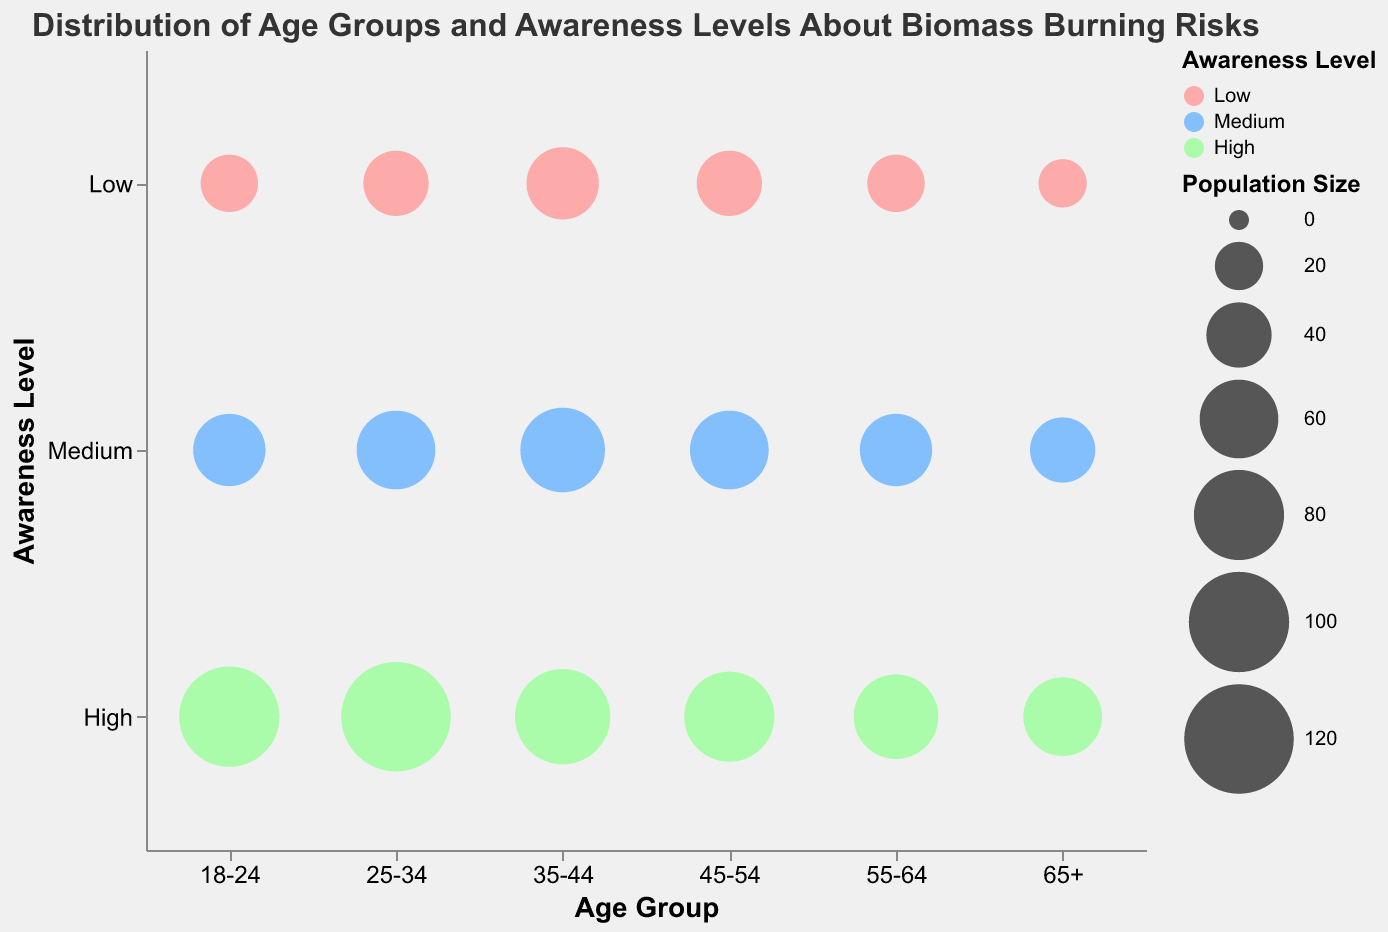What is the title of the chart? The title is displayed at the top of the chart and usually provides an overview of what the data represents. In this case, the words in the largest font at the top are the title.
Answer: Distribution of Age Groups and Awareness Levels About Biomass Burning Risks How many age groups are represented in the chart? The number of unique age groups can be counted on the x-axis. Each label on this axis indicates a unique age group.
Answer: 6 Which age group has the highest awareness level with the largest bubble size? Identify the 'High' awareness level on the y-axis and look at the bubble sizes for each age group in that row. The largest bubble will indicate the largest population size.
Answer: 25-34 Compare the bubble sizes for the 'Low' awareness level between the '18-24' and '65+' age groups. Which one is larger? Locate the 'Low' awareness level on the y-axis, then compare the bubbles for the '18-24' and '65+' age groups. The bubble with the larger size represents the larger population.
Answer: 18-24 What is the population size for the 'Medium' awareness level in the '35-44' age group? Find the intersection of the '35-44' age group on the x-axis and 'Medium' awareness level on the y-axis. The tooltip or the size of the bubble can provide an estimate of the population size.
Answer: 70 Which age group has the smallest population size for any awareness level? Look for the smallest bubble in the chart for any awareness level across all age groups.
Answer: 65+ at Low awareness level Is there a significant difference in population size for 'High' awareness levels across different age groups? Compare the bubble sizes in the row corresponding to 'High' awareness level across all age groups. Take note of any significantly larger or smaller bubbles.
Answer: Yes Among the age groups, which one has the smallest difference in population size between 'Low' and 'High' awareness levels? For each age group, calculate the difference in bubble size between 'Low' and 'High' awareness levels. The smallest difference indicates the age group with the least variation.
Answer: 55-64 How does the population size for 'Medium' awareness level compare between the '25-34' and '55-64' age groups? Locate the 'Medium' awareness level row and compare the sizes of the bubbles between the '25-34' and '55-64' age groups.
Answer: 25-34 is larger What is the most populated awareness level for the '45-54' age group? For the '45-54' age group, compare the sizes of the bubbles for 'Low', 'Medium', and 'High' awareness levels. The largest bubble indicates the most populated awareness level.
Answer: High 